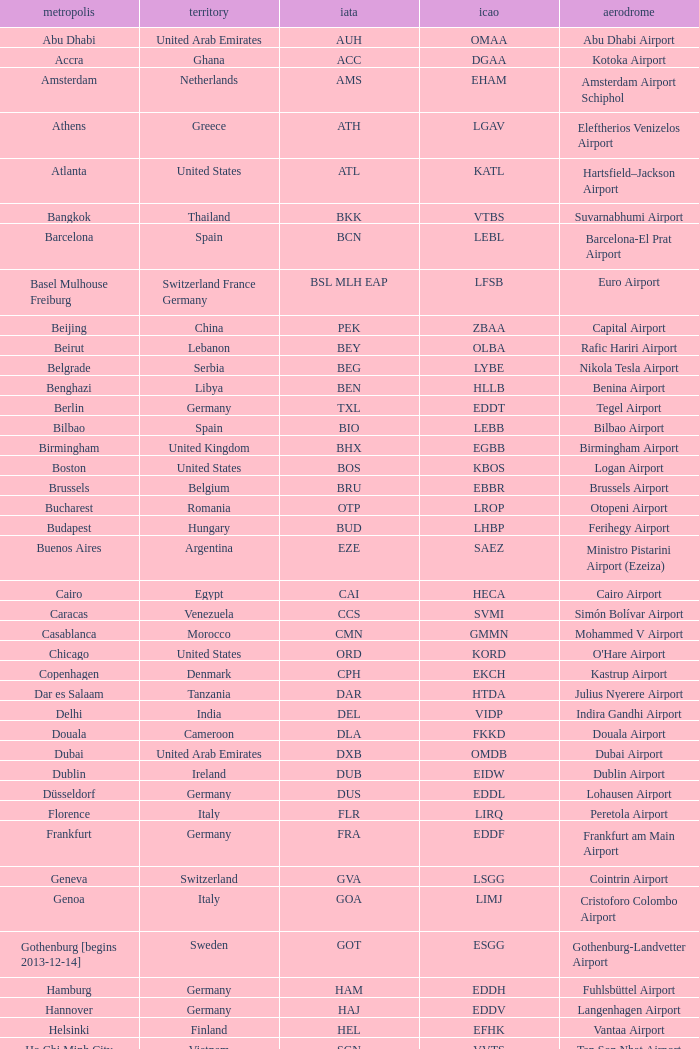What is the ICAO of Lohausen airport? EDDL. Could you parse the entire table? {'header': ['metropolis', 'territory', 'iata', 'icao', 'aerodrome'], 'rows': [['Abu Dhabi', 'United Arab Emirates', 'AUH', 'OMAA', 'Abu Dhabi Airport'], ['Accra', 'Ghana', 'ACC', 'DGAA', 'Kotoka Airport'], ['Amsterdam', 'Netherlands', 'AMS', 'EHAM', 'Amsterdam Airport Schiphol'], ['Athens', 'Greece', 'ATH', 'LGAV', 'Eleftherios Venizelos Airport'], ['Atlanta', 'United States', 'ATL', 'KATL', 'Hartsfield–Jackson Airport'], ['Bangkok', 'Thailand', 'BKK', 'VTBS', 'Suvarnabhumi Airport'], ['Barcelona', 'Spain', 'BCN', 'LEBL', 'Barcelona-El Prat Airport'], ['Basel Mulhouse Freiburg', 'Switzerland France Germany', 'BSL MLH EAP', 'LFSB', 'Euro Airport'], ['Beijing', 'China', 'PEK', 'ZBAA', 'Capital Airport'], ['Beirut', 'Lebanon', 'BEY', 'OLBA', 'Rafic Hariri Airport'], ['Belgrade', 'Serbia', 'BEG', 'LYBE', 'Nikola Tesla Airport'], ['Benghazi', 'Libya', 'BEN', 'HLLB', 'Benina Airport'], ['Berlin', 'Germany', 'TXL', 'EDDT', 'Tegel Airport'], ['Bilbao', 'Spain', 'BIO', 'LEBB', 'Bilbao Airport'], ['Birmingham', 'United Kingdom', 'BHX', 'EGBB', 'Birmingham Airport'], ['Boston', 'United States', 'BOS', 'KBOS', 'Logan Airport'], ['Brussels', 'Belgium', 'BRU', 'EBBR', 'Brussels Airport'], ['Bucharest', 'Romania', 'OTP', 'LROP', 'Otopeni Airport'], ['Budapest', 'Hungary', 'BUD', 'LHBP', 'Ferihegy Airport'], ['Buenos Aires', 'Argentina', 'EZE', 'SAEZ', 'Ministro Pistarini Airport (Ezeiza)'], ['Cairo', 'Egypt', 'CAI', 'HECA', 'Cairo Airport'], ['Caracas', 'Venezuela', 'CCS', 'SVMI', 'Simón Bolívar Airport'], ['Casablanca', 'Morocco', 'CMN', 'GMMN', 'Mohammed V Airport'], ['Chicago', 'United States', 'ORD', 'KORD', "O'Hare Airport"], ['Copenhagen', 'Denmark', 'CPH', 'EKCH', 'Kastrup Airport'], ['Dar es Salaam', 'Tanzania', 'DAR', 'HTDA', 'Julius Nyerere Airport'], ['Delhi', 'India', 'DEL', 'VIDP', 'Indira Gandhi Airport'], ['Douala', 'Cameroon', 'DLA', 'FKKD', 'Douala Airport'], ['Dubai', 'United Arab Emirates', 'DXB', 'OMDB', 'Dubai Airport'], ['Dublin', 'Ireland', 'DUB', 'EIDW', 'Dublin Airport'], ['Düsseldorf', 'Germany', 'DUS', 'EDDL', 'Lohausen Airport'], ['Florence', 'Italy', 'FLR', 'LIRQ', 'Peretola Airport'], ['Frankfurt', 'Germany', 'FRA', 'EDDF', 'Frankfurt am Main Airport'], ['Geneva', 'Switzerland', 'GVA', 'LSGG', 'Cointrin Airport'], ['Genoa', 'Italy', 'GOA', 'LIMJ', 'Cristoforo Colombo Airport'], ['Gothenburg [begins 2013-12-14]', 'Sweden', 'GOT', 'ESGG', 'Gothenburg-Landvetter Airport'], ['Hamburg', 'Germany', 'HAM', 'EDDH', 'Fuhlsbüttel Airport'], ['Hannover', 'Germany', 'HAJ', 'EDDV', 'Langenhagen Airport'], ['Helsinki', 'Finland', 'HEL', 'EFHK', 'Vantaa Airport'], ['Ho Chi Minh City', 'Vietnam', 'SGN', 'VVTS', 'Tan Son Nhat Airport'], ['Hong Kong', 'Hong Kong', 'HKG', 'VHHH', 'Chek Lap Kok Airport'], ['Istanbul', 'Turkey', 'IST', 'LTBA', 'Atatürk Airport'], ['Jakarta', 'Indonesia', 'CGK', 'WIII', 'Soekarno–Hatta Airport'], ['Jeddah', 'Saudi Arabia', 'JED', 'OEJN', 'King Abdulaziz Airport'], ['Johannesburg', 'South Africa', 'JNB', 'FAJS', 'OR Tambo Airport'], ['Karachi', 'Pakistan', 'KHI', 'OPKC', 'Jinnah Airport'], ['Kiev', 'Ukraine', 'KBP', 'UKBB', 'Boryspil International Airport'], ['Lagos', 'Nigeria', 'LOS', 'DNMM', 'Murtala Muhammed Airport'], ['Libreville', 'Gabon', 'LBV', 'FOOL', "Leon M'ba Airport"], ['Lisbon', 'Portugal', 'LIS', 'LPPT', 'Portela Airport'], ['London', 'United Kingdom', 'LCY', 'EGLC', 'City Airport'], ['London [begins 2013-12-14]', 'United Kingdom', 'LGW', 'EGKK', 'Gatwick Airport'], ['London', 'United Kingdom', 'LHR', 'EGLL', 'Heathrow Airport'], ['Los Angeles', 'United States', 'LAX', 'KLAX', 'Los Angeles International Airport'], ['Lugano', 'Switzerland', 'LUG', 'LSZA', 'Agno Airport'], ['Luxembourg City', 'Luxembourg', 'LUX', 'ELLX', 'Findel Airport'], ['Lyon', 'France', 'LYS', 'LFLL', 'Saint-Exupéry Airport'], ['Madrid', 'Spain', 'MAD', 'LEMD', 'Madrid-Barajas Airport'], ['Malabo', 'Equatorial Guinea', 'SSG', 'FGSL', 'Saint Isabel Airport'], ['Malaga', 'Spain', 'AGP', 'LEMG', 'Málaga-Costa del Sol Airport'], ['Manchester', 'United Kingdom', 'MAN', 'EGCC', 'Ringway Airport'], ['Manila', 'Philippines', 'MNL', 'RPLL', 'Ninoy Aquino Airport'], ['Marrakech [begins 2013-11-01]', 'Morocco', 'RAK', 'GMMX', 'Menara Airport'], ['Miami', 'United States', 'MIA', 'KMIA', 'Miami Airport'], ['Milan', 'Italy', 'MXP', 'LIMC', 'Malpensa Airport'], ['Minneapolis', 'United States', 'MSP', 'KMSP', 'Minneapolis Airport'], ['Montreal', 'Canada', 'YUL', 'CYUL', 'Pierre Elliott Trudeau Airport'], ['Moscow', 'Russia', 'DME', 'UUDD', 'Domodedovo Airport'], ['Mumbai', 'India', 'BOM', 'VABB', 'Chhatrapati Shivaji Airport'], ['Munich', 'Germany', 'MUC', 'EDDM', 'Franz Josef Strauss Airport'], ['Muscat', 'Oman', 'MCT', 'OOMS', 'Seeb Airport'], ['Nairobi', 'Kenya', 'NBO', 'HKJK', 'Jomo Kenyatta Airport'], ['Newark', 'United States', 'EWR', 'KEWR', 'Liberty Airport'], ['New York City', 'United States', 'JFK', 'KJFK', 'John F Kennedy Airport'], ['Nice', 'France', 'NCE', 'LFMN', "Côte d'Azur Airport"], ['Nuremberg', 'Germany', 'NUE', 'EDDN', 'Nuremberg Airport'], ['Oslo', 'Norway', 'OSL', 'ENGM', 'Gardermoen Airport'], ['Palma de Mallorca', 'Spain', 'PMI', 'LFPA', 'Palma de Mallorca Airport'], ['Paris', 'France', 'CDG', 'LFPG', 'Charles de Gaulle Airport'], ['Porto', 'Portugal', 'OPO', 'LPPR', 'Francisco de Sa Carneiro Airport'], ['Prague', 'Czech Republic', 'PRG', 'LKPR', 'Ruzyně Airport'], ['Riga', 'Latvia', 'RIX', 'EVRA', 'Riga Airport'], ['Rio de Janeiro [resumes 2014-7-14]', 'Brazil', 'GIG', 'SBGL', 'Galeão Airport'], ['Riyadh', 'Saudi Arabia', 'RUH', 'OERK', 'King Khalid Airport'], ['Rome', 'Italy', 'FCO', 'LIRF', 'Leonardo da Vinci Airport'], ['Saint Petersburg', 'Russia', 'LED', 'ULLI', 'Pulkovo Airport'], ['San Francisco', 'United States', 'SFO', 'KSFO', 'San Francisco Airport'], ['Santiago', 'Chile', 'SCL', 'SCEL', 'Comodoro Arturo Benitez Airport'], ['São Paulo', 'Brazil', 'GRU', 'SBGR', 'Guarulhos Airport'], ['Sarajevo', 'Bosnia and Herzegovina', 'SJJ', 'LQSA', 'Butmir Airport'], ['Seattle', 'United States', 'SEA', 'KSEA', 'Sea-Tac Airport'], ['Shanghai', 'China', 'PVG', 'ZSPD', 'Pudong Airport'], ['Singapore', 'Singapore', 'SIN', 'WSSS', 'Changi Airport'], ['Skopje', 'Republic of Macedonia', 'SKP', 'LWSK', 'Alexander the Great Airport'], ['Sofia', 'Bulgaria', 'SOF', 'LBSF', 'Vrazhdebna Airport'], ['Stockholm', 'Sweden', 'ARN', 'ESSA', 'Arlanda Airport'], ['Stuttgart', 'Germany', 'STR', 'EDDS', 'Echterdingen Airport'], ['Taipei', 'Taiwan', 'TPE', 'RCTP', 'Taoyuan Airport'], ['Tehran', 'Iran', 'IKA', 'OIIE', 'Imam Khomeini Airport'], ['Tel Aviv', 'Israel', 'TLV', 'LLBG', 'Ben Gurion Airport'], ['Thessaloniki', 'Greece', 'SKG', 'LGTS', 'Macedonia Airport'], ['Tirana', 'Albania', 'TIA', 'LATI', 'Nënë Tereza Airport'], ['Tokyo', 'Japan', 'NRT', 'RJAA', 'Narita Airport'], ['Toronto', 'Canada', 'YYZ', 'CYYZ', 'Pearson Airport'], ['Tripoli', 'Libya', 'TIP', 'HLLT', 'Tripoli Airport'], ['Tunis', 'Tunisia', 'TUN', 'DTTA', 'Carthage Airport'], ['Turin', 'Italy', 'TRN', 'LIMF', 'Sandro Pertini Airport'], ['Valencia', 'Spain', 'VLC', 'LEVC', 'Valencia Airport'], ['Venice', 'Italy', 'VCE', 'LIPZ', 'Marco Polo Airport'], ['Vienna', 'Austria', 'VIE', 'LOWW', 'Schwechat Airport'], ['Warsaw', 'Poland', 'WAW', 'EPWA', 'Frederic Chopin Airport'], ['Washington DC', 'United States', 'IAD', 'KIAD', 'Dulles Airport'], ['Yaounde', 'Cameroon', 'NSI', 'FKYS', 'Yaounde Nsimalen Airport'], ['Yerevan', 'Armenia', 'EVN', 'UDYZ', 'Zvartnots Airport'], ['Zurich', 'Switzerland', 'ZRH', 'LSZH', 'Zurich Airport']]} 